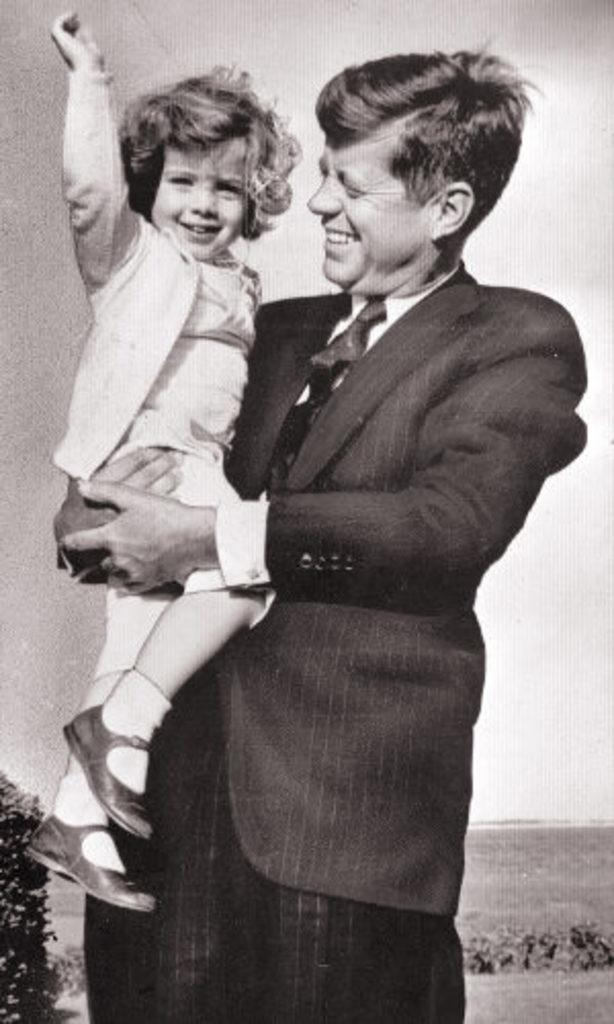Who is the main subject in the image? A man is standing in the middle of the image. What is the man doing in the image? The man is holding a baby. How are the man and the baby feeling in the image? Both the man and the baby are smiling. What can be seen in the background of the image? There are plants visible in the background. What is visible at the top of the image? The sky is visible at the top of the image. What type of stamp can be seen on the baby's forehead in the image? There is no stamp present on the baby's forehead in the image. 